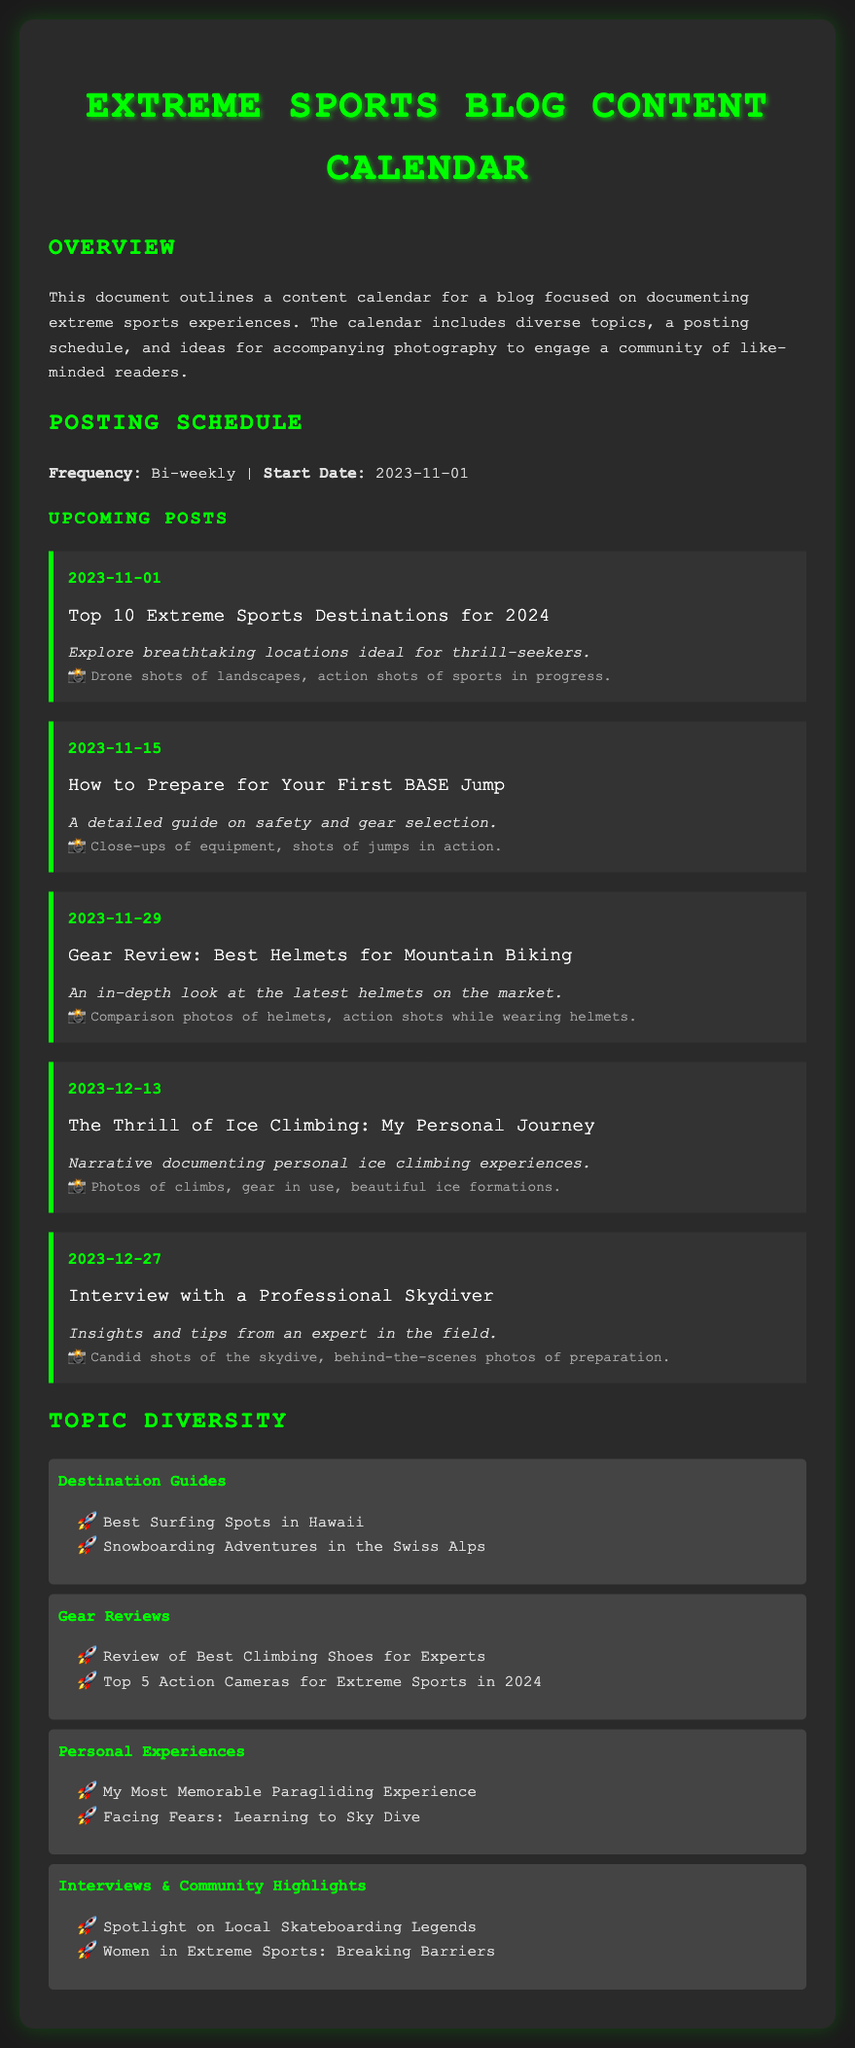What is the first post date? The first post date listed in the document is 2023-11-01.
Answer: 2023-11-01 How frequently will posts be published? The document states that posts will be published bi-weekly.
Answer: Bi-weekly What is the topic of the post on 2023-11-15? The topic for the post scheduled on 2023-11-15 is about preparing for BASE jumps.
Answer: How to Prepare for Your First BASE Jump What is a suggested photography idea for the ice climbing post? The document lists beautiful ice formations as a suggested photography idea for the ice climbing post.
Answer: Beautiful ice formations Which category includes "My Most Memorable Paragliding Experience"? The mentioned post is included in the Personal Experiences category.
Answer: Personal Experiences How many gear reviews are mentioned in the diversity section? There are two gear reviews listed in the Gear Reviews category.
Answer: 2 What date is the interview with the professional skydiver scheduled for? The interview is slated for the date 2023-12-27.
Answer: 2023-12-27 What type of content is highlighted under Community Highlights? The community highlights section features spotlights on local skateboarding legends.
Answer: Spotlight on Local Skateboarding Legends 